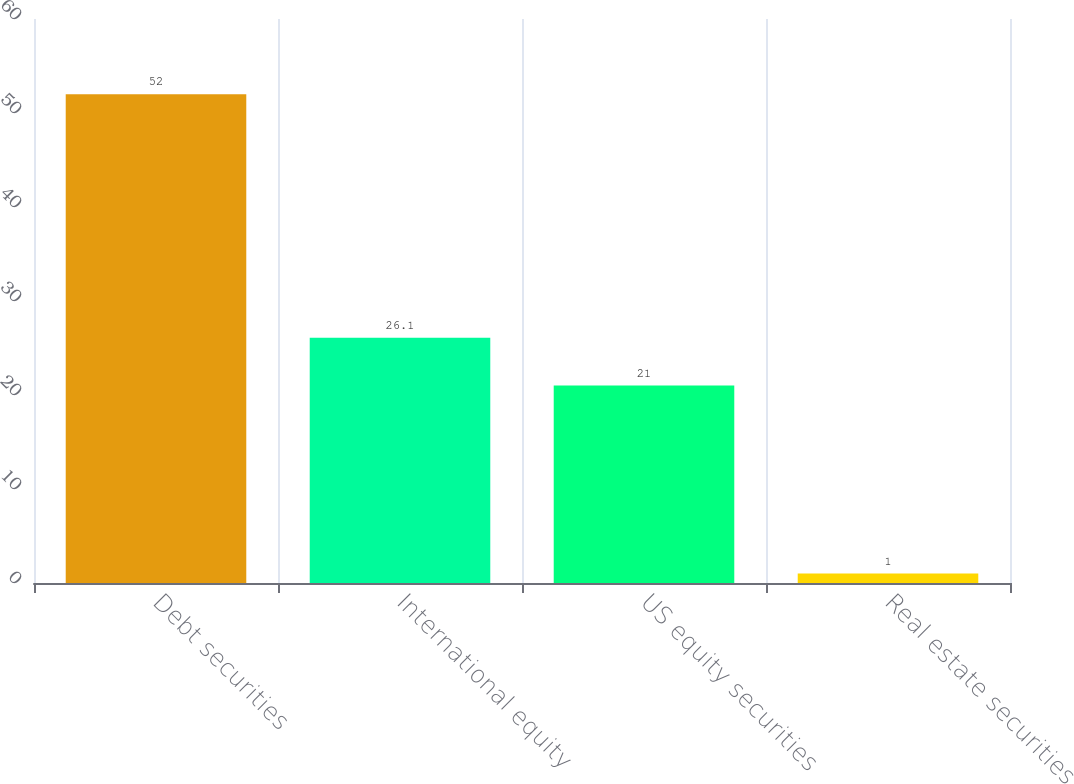Convert chart to OTSL. <chart><loc_0><loc_0><loc_500><loc_500><bar_chart><fcel>Debt securities<fcel>International equity<fcel>US equity securities<fcel>Real estate securities<nl><fcel>52<fcel>26.1<fcel>21<fcel>1<nl></chart> 